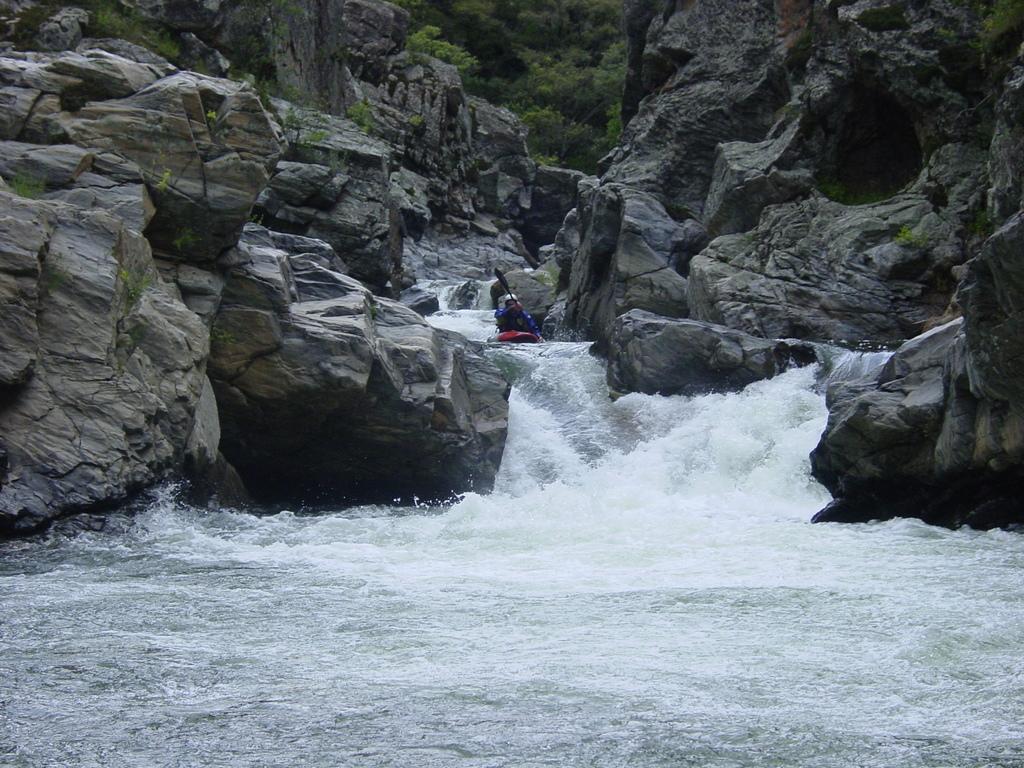Can you describe this image briefly? In this image we can see a person riding a boat on the water and holding a paddle. And we can see there are rocks and trees. 